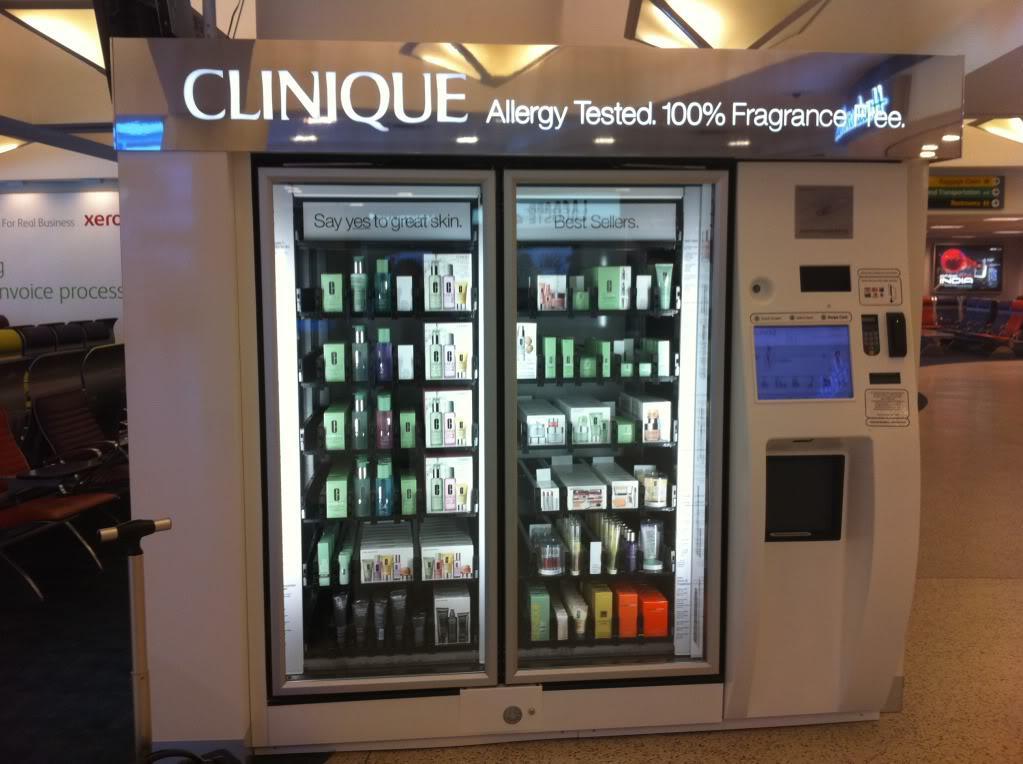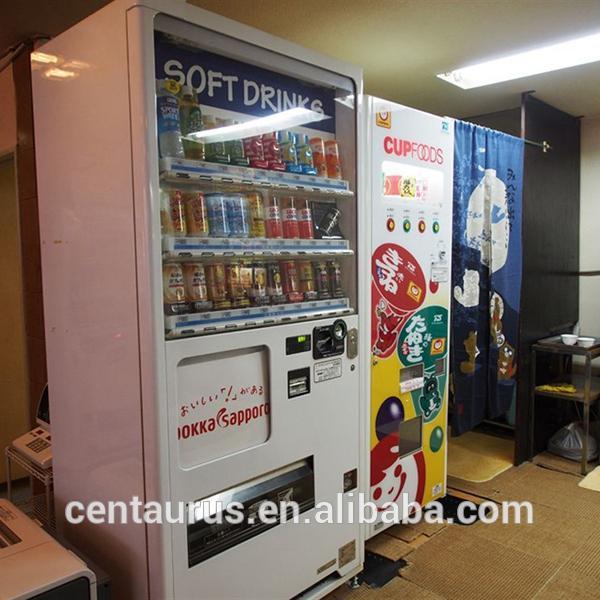The first image is the image on the left, the second image is the image on the right. For the images displayed, is the sentence "Neither image has an actual human being that is standing up." factually correct? Answer yes or no. Yes. The first image is the image on the left, the second image is the image on the right. Analyze the images presented: Is the assertion "Somewhere in one image, a back-turned person stands in front of a lit screen of some type." valid? Answer yes or no. No. 